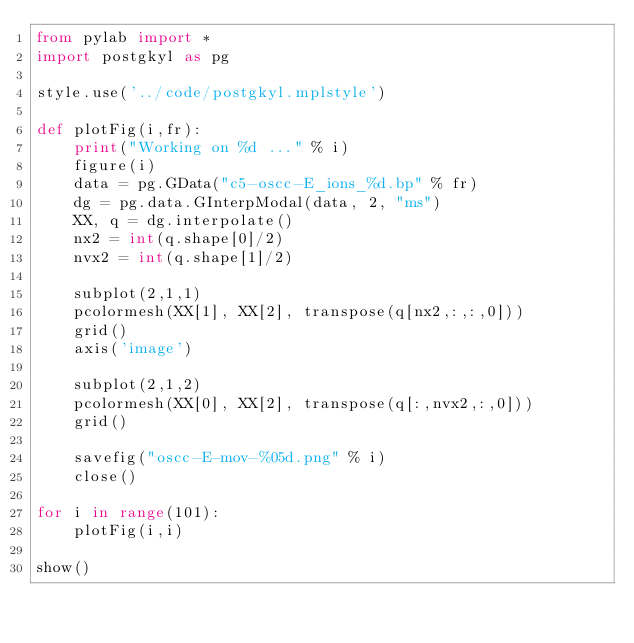<code> <loc_0><loc_0><loc_500><loc_500><_Python_>from pylab import *
import postgkyl as pg

style.use('../code/postgkyl.mplstyle')

def plotFig(i,fr):
    print("Working on %d ..." % i)
    figure(i)
    data = pg.GData("c5-oscc-E_ions_%d.bp" % fr)
    dg = pg.data.GInterpModal(data, 2, "ms")
    XX, q = dg.interpolate()
    nx2 = int(q.shape[0]/2)
    nvx2 = int(q.shape[1]/2)    

    subplot(2,1,1)
    pcolormesh(XX[1], XX[2], transpose(q[nx2,:,:,0]))
    grid()
    axis('image')

    subplot(2,1,2)
    pcolormesh(XX[0], XX[2], transpose(q[:,nvx2,:,0]))
    grid()

    savefig("oscc-E-mov-%05d.png" % i)
    close()    

for i in range(101):
    plotFig(i,i)
    
show()

</code> 